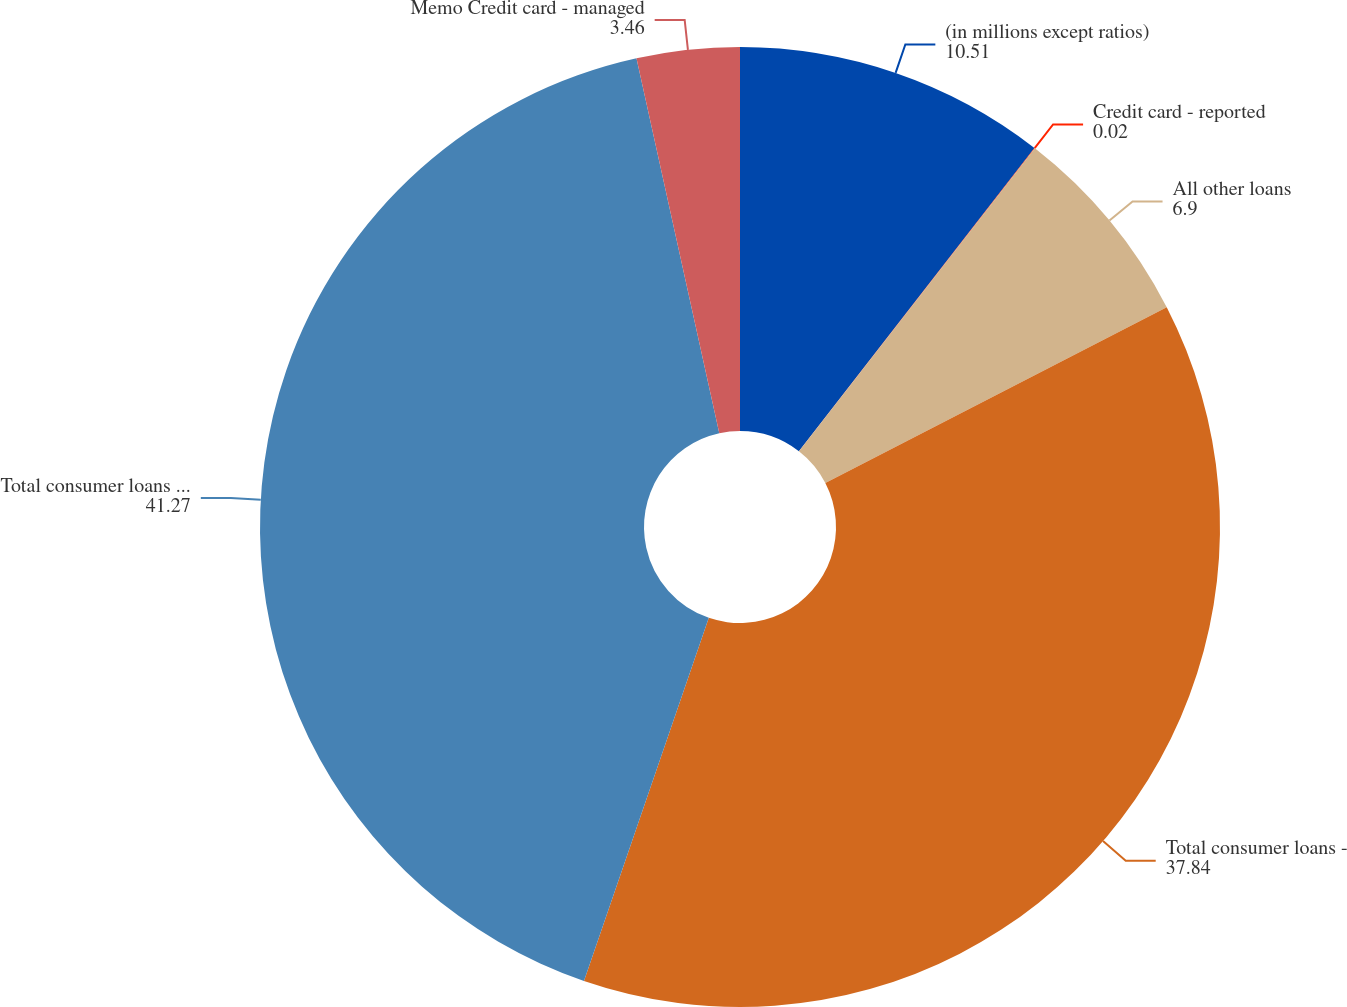Convert chart to OTSL. <chart><loc_0><loc_0><loc_500><loc_500><pie_chart><fcel>(in millions except ratios)<fcel>Credit card - reported<fcel>All other loans<fcel>Total consumer loans -<fcel>Total consumer loans - managed<fcel>Memo Credit card - managed<nl><fcel>10.51%<fcel>0.02%<fcel>6.9%<fcel>37.84%<fcel>41.27%<fcel>3.46%<nl></chart> 